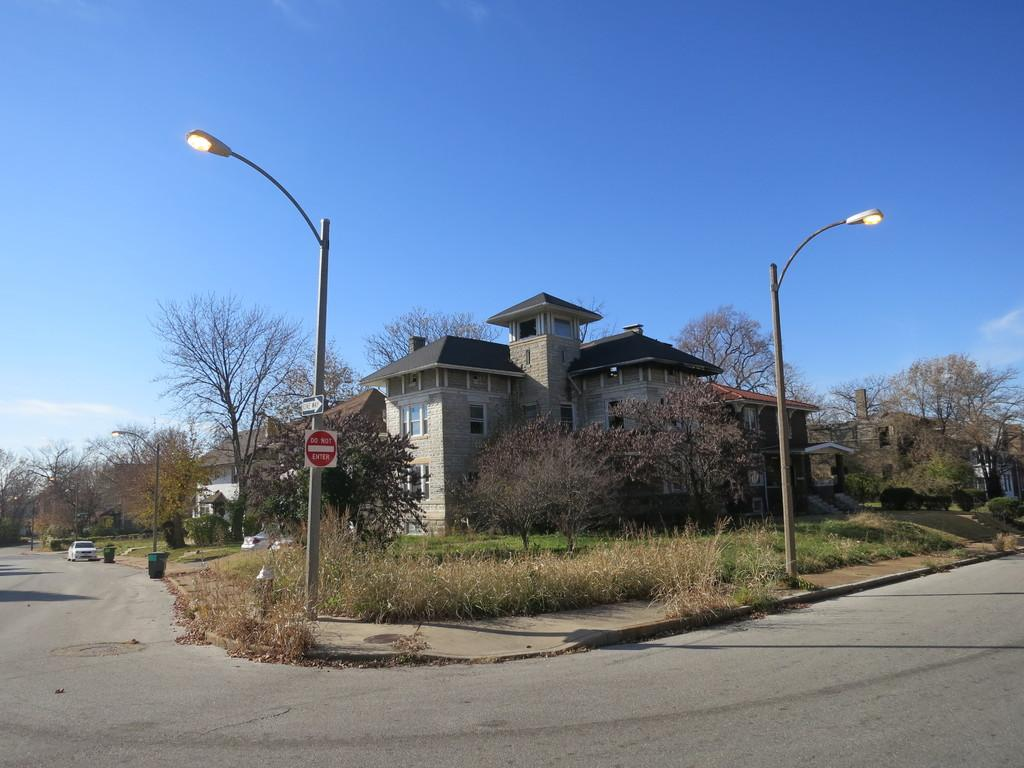<image>
Present a compact description of the photo's key features. The sign on the lamp post infront of the house warns people do not enter. 